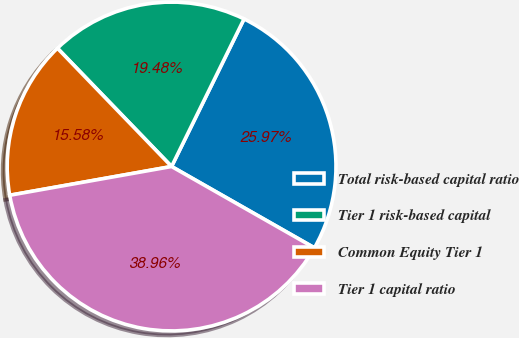Convert chart. <chart><loc_0><loc_0><loc_500><loc_500><pie_chart><fcel>Total risk-based capital ratio<fcel>Tier 1 risk-based capital<fcel>Common Equity Tier 1<fcel>Tier 1 capital ratio<nl><fcel>25.97%<fcel>19.48%<fcel>15.58%<fcel>38.96%<nl></chart> 